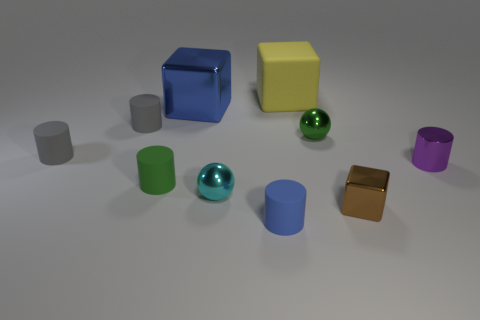Subtract all purple cylinders. How many cylinders are left? 4 Subtract all shiny cylinders. How many cylinders are left? 4 Subtract all red cylinders. Subtract all blue spheres. How many cylinders are left? 5 Subtract all cubes. How many objects are left? 7 Add 5 gray rubber objects. How many gray rubber objects are left? 7 Add 7 blue things. How many blue things exist? 9 Subtract 0 brown spheres. How many objects are left? 10 Subtract all small balls. Subtract all green matte objects. How many objects are left? 7 